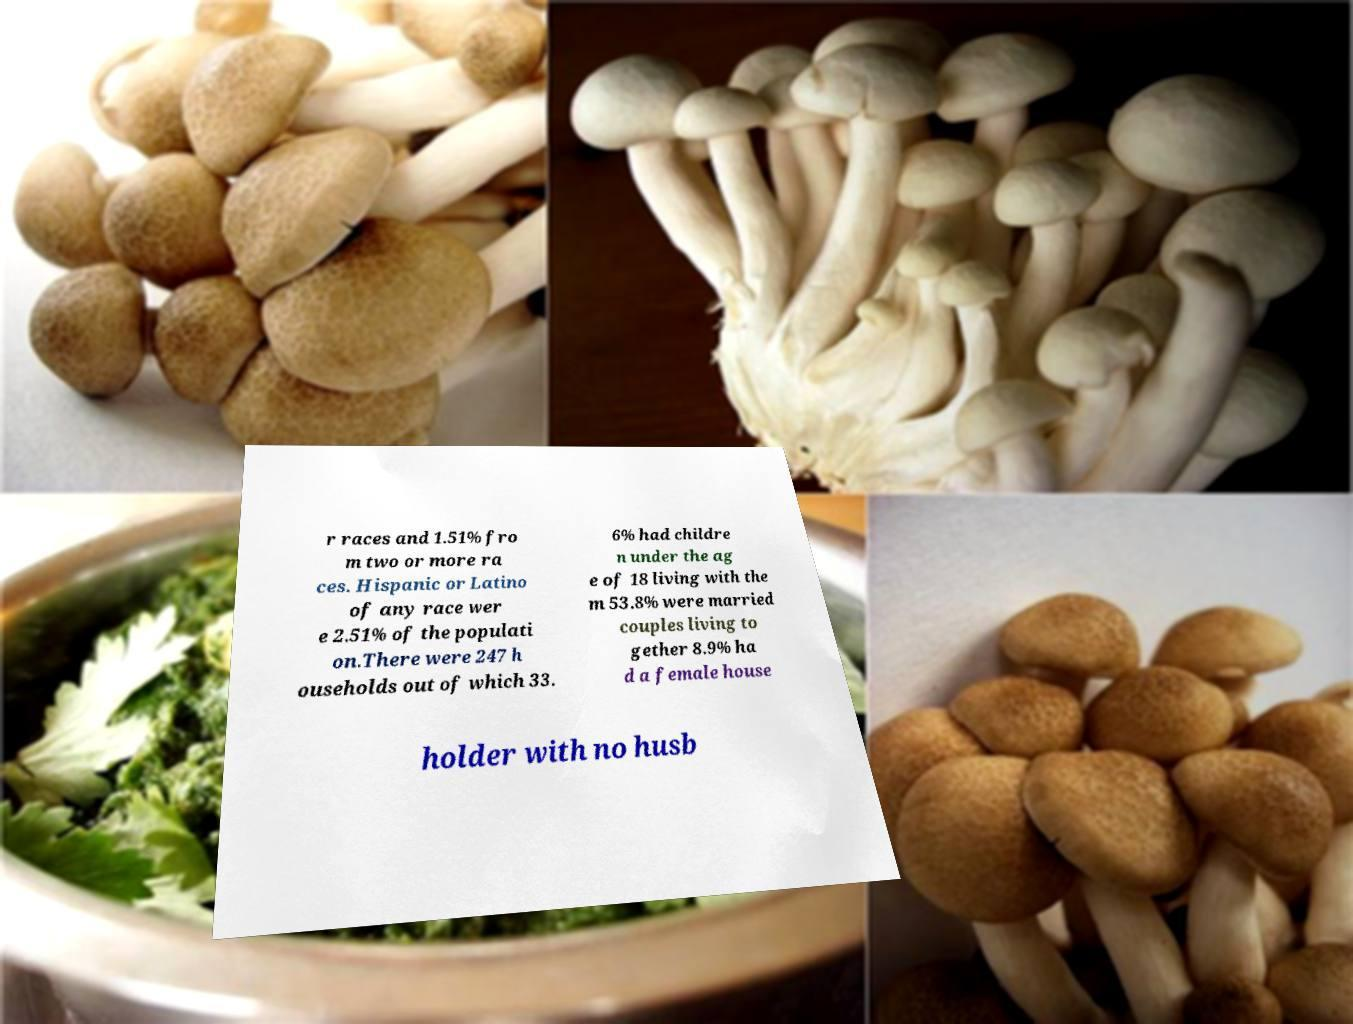Could you extract and type out the text from this image? r races and 1.51% fro m two or more ra ces. Hispanic or Latino of any race wer e 2.51% of the populati on.There were 247 h ouseholds out of which 33. 6% had childre n under the ag e of 18 living with the m 53.8% were married couples living to gether 8.9% ha d a female house holder with no husb 